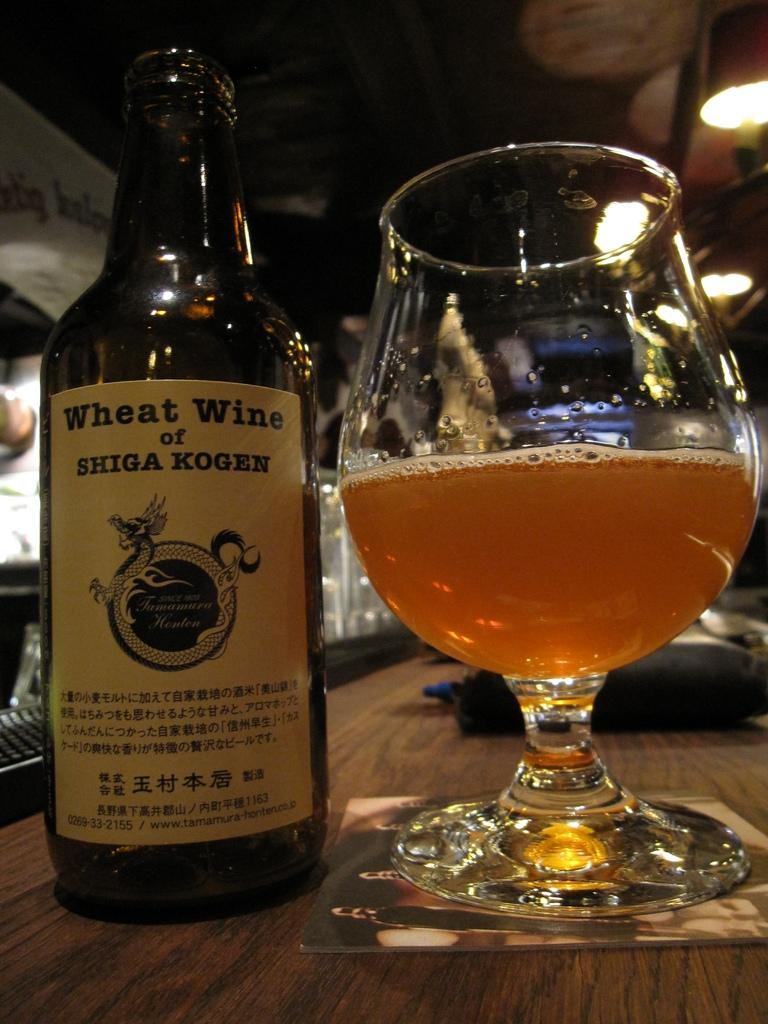<image>
Relay a brief, clear account of the picture shown. A bottle of Wheat Wine is next to a glass that is half full. 